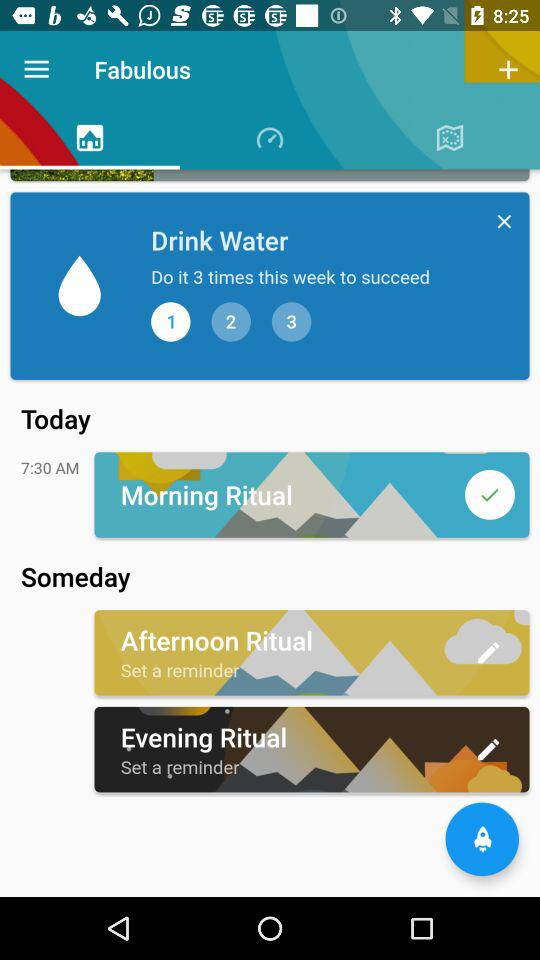How many rituals are scheduled for this week?
Answer the question using a single word or phrase. 3 